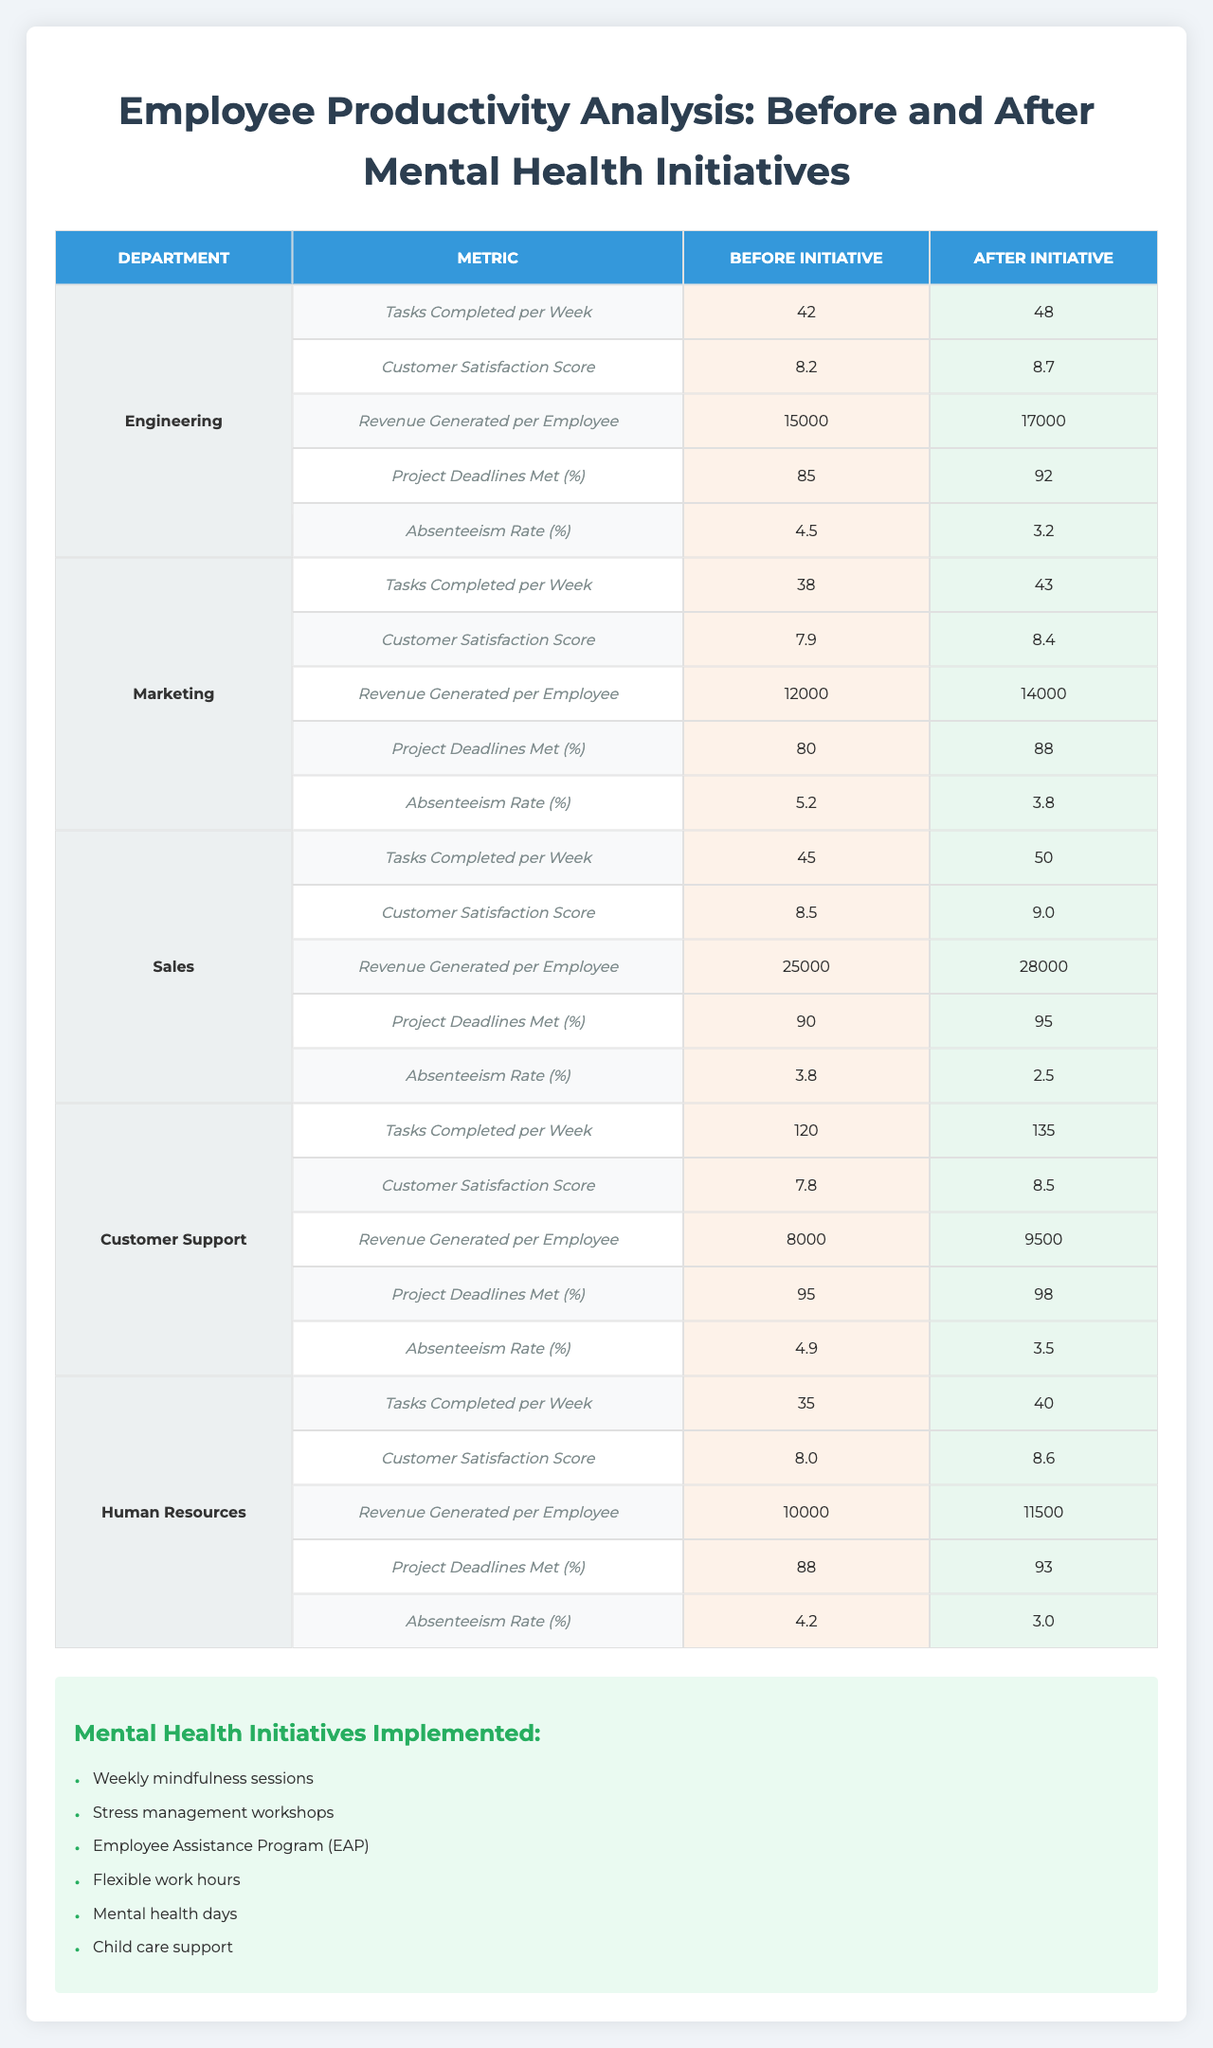What was the Tasks Completed per Week by the Sales department before the mental health initiative? Referring to the table, the Tasks Completed per Week by the Sales department before the initiative is listed as 45.
Answer: 45 How much did the Customer Satisfaction Score improve for the Engineering department? The Customer Satisfaction Score for Engineering before the initiative was 8.2, and after it was 8.7. The improvement is 8.7 - 8.2 = 0.5.
Answer: 0.5 Is the Revenue Generated per Employee for the Marketing department higher after the initiative? Comparing the values in the table, the Revenue Generated per Employee for Marketing was 12,000 before and increased to 14,000 after, making it higher.
Answer: Yes Which department had the highest decrease in Absenteeism Rate after the initiative? Looking at the Absenteeism Rates before and after the initiative, Sales had an absenteeism rate of 3.8 before and 2.5 after, resulting in a decrease of 1.3, which is the highest decrease compared to other departments.
Answer: Sales What was the average Customer Satisfaction Score for all departments after the mental health initiative? The Customer Satisfaction Scores after the initiative are: Engineering (8.7), Marketing (8.4), Sales (9.0), Customer Support (8.5), and Human Resources (8.6). Adding these: 8.7 + 8.4 + 9.0 + 8.5 + 8.6 = 43.2. There are 5 departments, so the average is 43.2 / 5 = 8.64.
Answer: 8.64 Did the overall job satisfaction increase after the mental health initiatives were implemented? Comparing the overall job satisfaction scores, it was 7.2 before the initiative and increased to 8.5 after, indicating an increase.
Answer: Yes What is the percentage increase in Project Deadlines Met for the Customer Support department? The percentage of Project Deadlines Met for Customer Support before the initiative was 95% and increased to 98% after. The increase is 98% - 95% = 3%, which is a percentage increase of \( (3 / 95) * 100 \approx 3.16\% \).
Answer: 3.16% Which productivity metric had the most significant improvement in the Sales department after the initiative? In the Sales department, the Revenue Generated per Employee improved from 25,000 before to 28,000 after, a difference of 3,000. This is larger than any other metric’s improvement in that department.
Answer: Revenue Generated per Employee What is the overall trend seen in the employee satisfaction regarding Mental Health Support after the initiative? The Mental Health Support score increased from 5.9 before the initiative to 8.7 after, showing a positive trend in employee satisfaction about mental health.
Answer: Positive trend How many initiatives were implemented in total, and what is the effect of these on employee productivity? A total of 6 mental health initiatives were implemented, and while the table indicates improvements across multiple productivity metrics post-initiative, the exact numerical effect varies by department and metric.
Answer: 6 initiatives; positive effect on productivity 